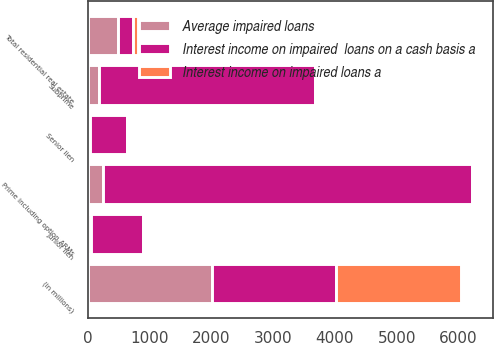Convert chart. <chart><loc_0><loc_0><loc_500><loc_500><stacked_bar_chart><ecel><fcel>(in millions)<fcel>Senior lien<fcel>Junior lien<fcel>Prime including option ARMs<fcel>Subprime<fcel>Total residential real estate<nl><fcel>Interest income on impaired  loans on a cash basis a<fcel>2012<fcel>610<fcel>848<fcel>5989<fcel>3494<fcel>238<nl><fcel>Average impaired loans<fcel>2012<fcel>27<fcel>42<fcel>238<fcel>183<fcel>490<nl><fcel>Interest income on impaired loans a<fcel>2012<fcel>12<fcel>16<fcel>28<fcel>31<fcel>87<nl></chart> 